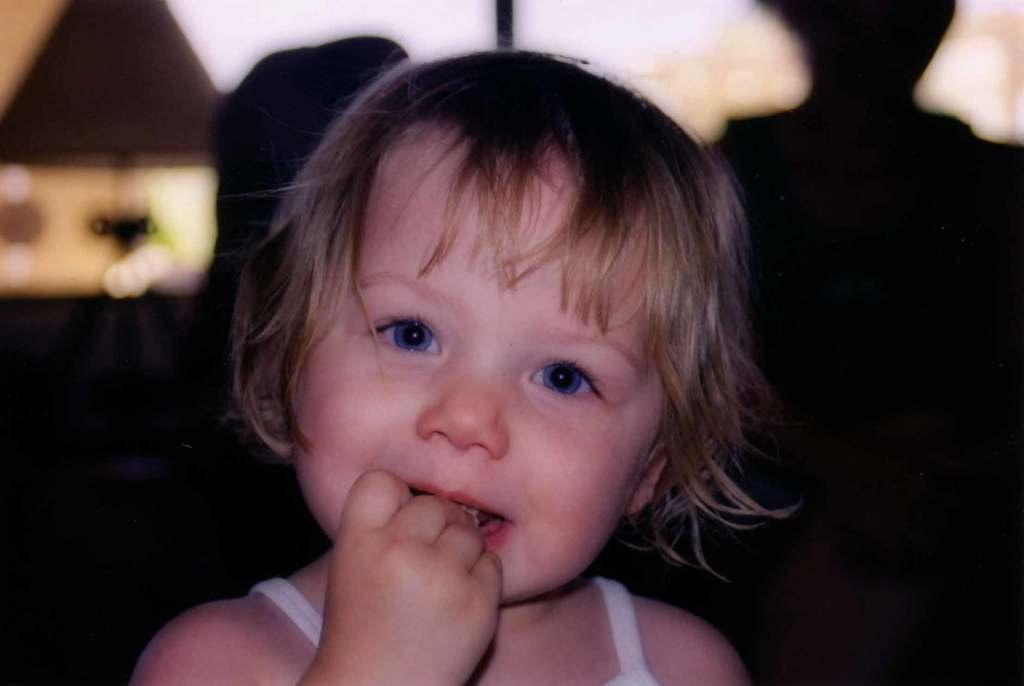What can be inferred about the location of the image? The image was likely taken indoors. What is the main subject in the foreground of the image? There is a kid in the foreground of the image. What is the kid doing in the image? The kid appears to be eating. What object is the kid holding in the image? The kid is holding an object. What can be seen in the background of the image? There is a lamp and other unspecified objects in the background of the image. What arithmetic problem is the kid solving in the image? There is no indication in the image that the kid is solving an arithmetic problem. What type of cover is on the table in the image? There is no table or cover present in the image. 